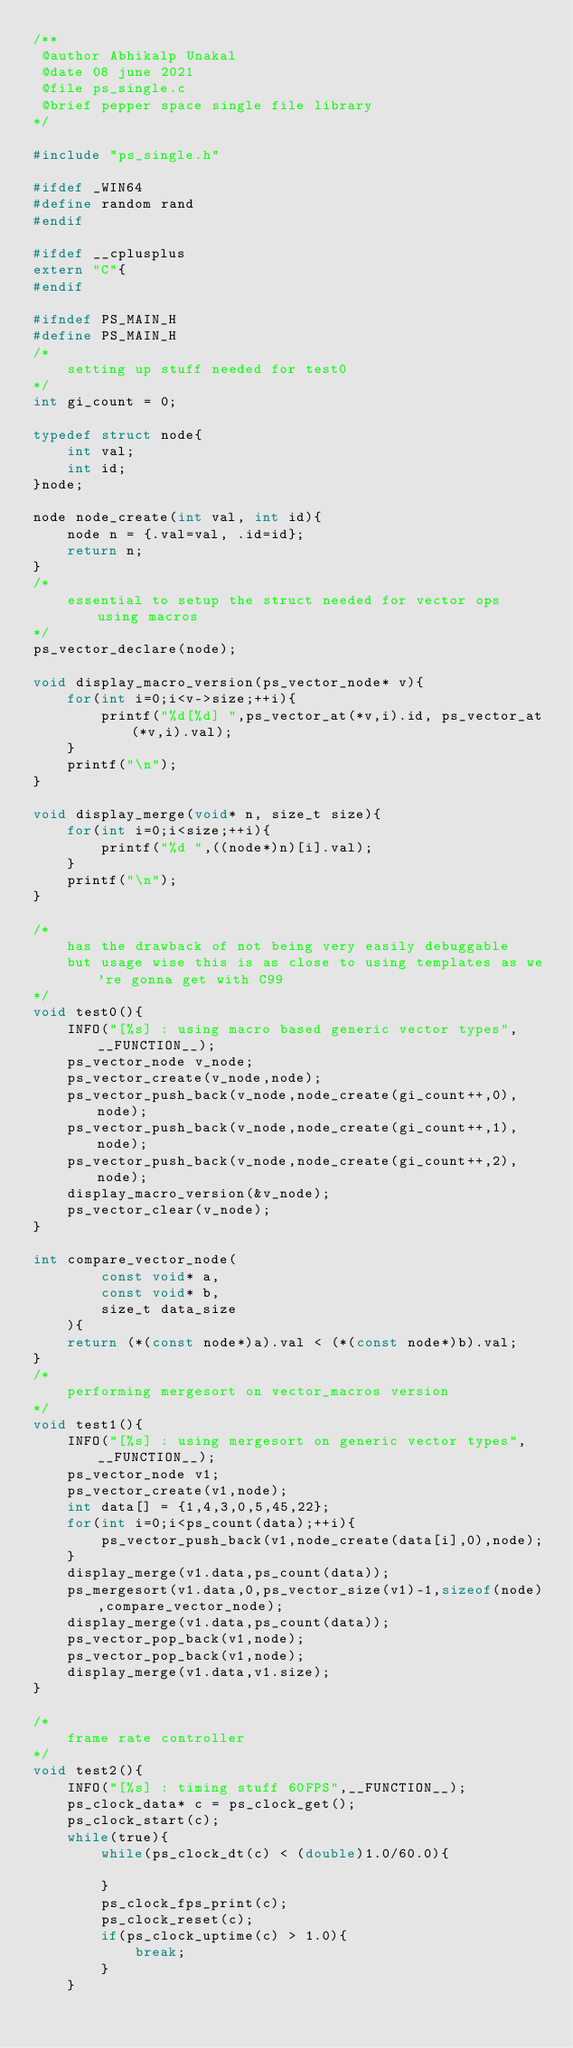<code> <loc_0><loc_0><loc_500><loc_500><_C_>/**
 @author Abhikalp Unakal
 @date 08 june 2021
 @file ps_single.c
 @brief pepper space single file library
*/

#include "ps_single.h"

#ifdef _WIN64
#define random rand
#endif

#ifdef __cplusplus
extern "C"{
#endif

#ifndef PS_MAIN_H
#define PS_MAIN_H
/*
    setting up stuff needed for test0
*/
int gi_count = 0;

typedef struct node{
    int val;
    int id;
}node;

node node_create(int val, int id){
    node n = {.val=val, .id=id};
    return n;
}
/*
    essential to setup the struct needed for vector ops using macros
*/
ps_vector_declare(node);

void display_macro_version(ps_vector_node* v){
    for(int i=0;i<v->size;++i){
        printf("%d[%d] ",ps_vector_at(*v,i).id, ps_vector_at(*v,i).val);
    }
    printf("\n");
}

void display_merge(void* n, size_t size){
    for(int i=0;i<size;++i){
        printf("%d ",((node*)n)[i].val);
    }
    printf("\n");
}

/*
    has the drawback of not being very easily debuggable
    but usage wise this is as close to using templates as we're gonna get with C99 
*/
void test0(){
    INFO("[%s] : using macro based generic vector types",__FUNCTION__);
    ps_vector_node v_node;
    ps_vector_create(v_node,node);
    ps_vector_push_back(v_node,node_create(gi_count++,0),node);
    ps_vector_push_back(v_node,node_create(gi_count++,1),node);
    ps_vector_push_back(v_node,node_create(gi_count++,2),node);
    display_macro_version(&v_node);
    ps_vector_clear(v_node);
}

int compare_vector_node(
        const void* a, 
        const void* b, 
        size_t data_size
    ){
    return (*(const node*)a).val < (*(const node*)b).val;
}
/*
    performing mergesort on vector_macros version
*/
void test1(){
    INFO("[%s] : using mergesort on generic vector types",__FUNCTION__);
    ps_vector_node v1;
    ps_vector_create(v1,node);
    int data[] = {1,4,3,0,5,45,22};
    for(int i=0;i<ps_count(data);++i){
        ps_vector_push_back(v1,node_create(data[i],0),node);
    }
    display_merge(v1.data,ps_count(data));
    ps_mergesort(v1.data,0,ps_vector_size(v1)-1,sizeof(node),compare_vector_node);
    display_merge(v1.data,ps_count(data));
    ps_vector_pop_back(v1,node);
    ps_vector_pop_back(v1,node);
    display_merge(v1.data,v1.size);
}

/*
    frame rate controller
*/
void test2(){
    INFO("[%s] : timing stuff 60FPS",__FUNCTION__);
    ps_clock_data* c = ps_clock_get();
    ps_clock_start(c);
    while(true){
        while(ps_clock_dt(c) < (double)1.0/60.0){
            
        }
        ps_clock_fps_print(c);
        ps_clock_reset(c);
        if(ps_clock_uptime(c) > 1.0){
            break;
        }
    }</code> 